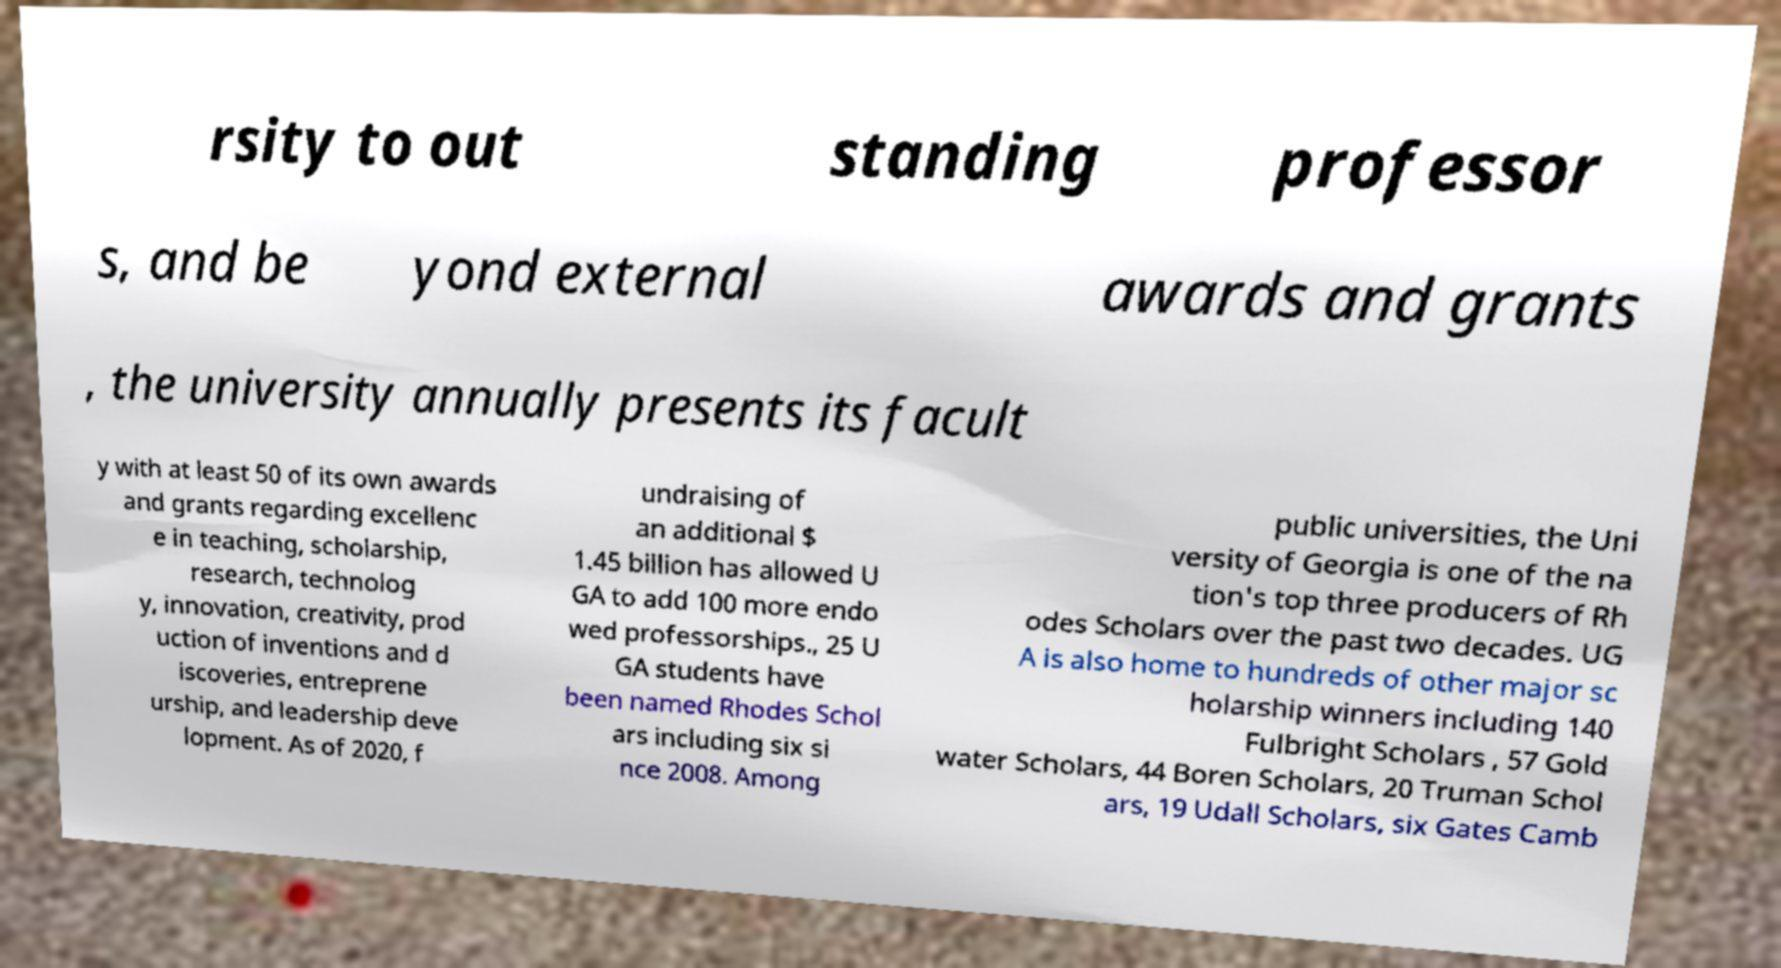I need the written content from this picture converted into text. Can you do that? rsity to out standing professor s, and be yond external awards and grants , the university annually presents its facult y with at least 50 of its own awards and grants regarding excellenc e in teaching, scholarship, research, technolog y, innovation, creativity, prod uction of inventions and d iscoveries, entreprene urship, and leadership deve lopment. As of 2020, f undraising of an additional $ 1.45 billion has allowed U GA to add 100 more endo wed professorships., 25 U GA students have been named Rhodes Schol ars including six si nce 2008. Among public universities, the Uni versity of Georgia is one of the na tion's top three producers of Rh odes Scholars over the past two decades. UG A is also home to hundreds of other major sc holarship winners including 140 Fulbright Scholars , 57 Gold water Scholars, 44 Boren Scholars, 20 Truman Schol ars, 19 Udall Scholars, six Gates Camb 